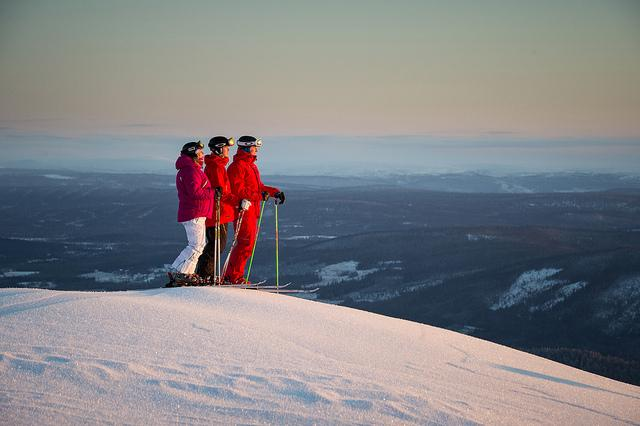What is the most likely time of day?

Choices:
A) midnight
B) sunset
C) noon
D) morning sunset 